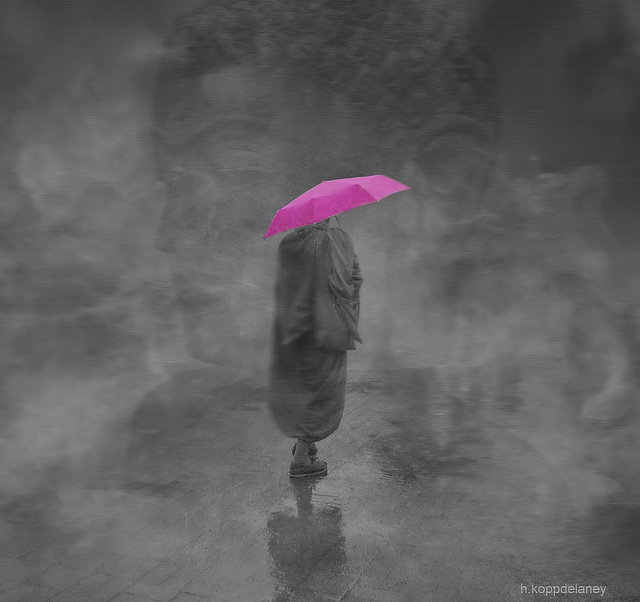Describe the objects in this image and their specific colors. I can see people in black and gray tones and umbrella in black, violet, purple, and gray tones in this image. 